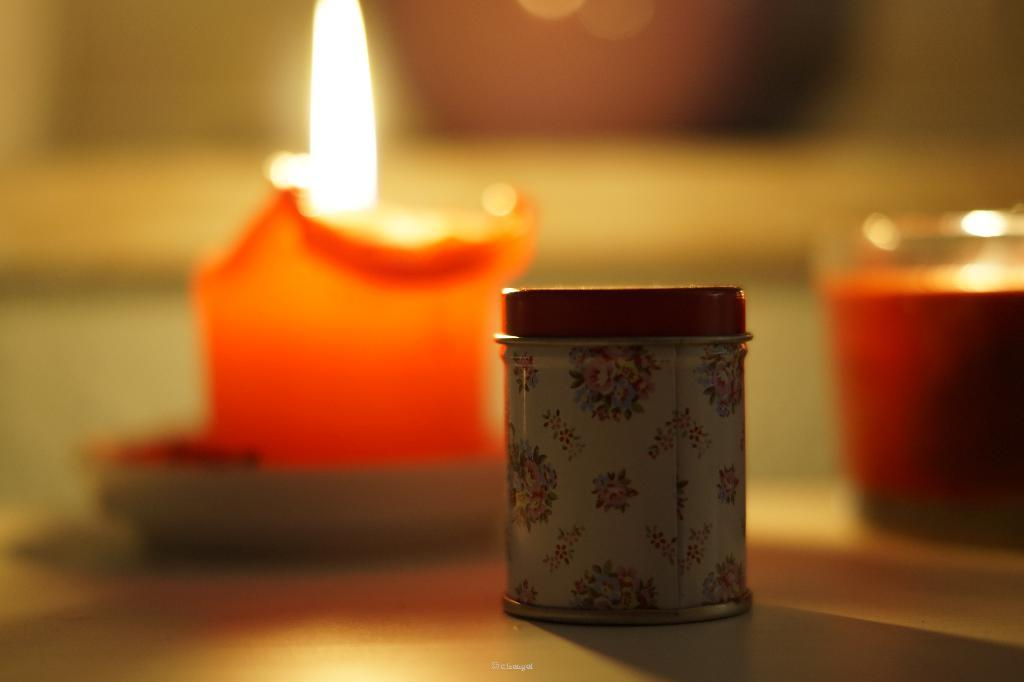What object can be seen in the background of the image? There is a candle in the background of the image. What other object is present in the image? There is a bottle in the image. How would you describe the background of the image? The background of the image appears blurry. What type of tooth is visible in the image? There is no tooth present in the image. What is the locket used for in the image? There is no locket present in the image. 